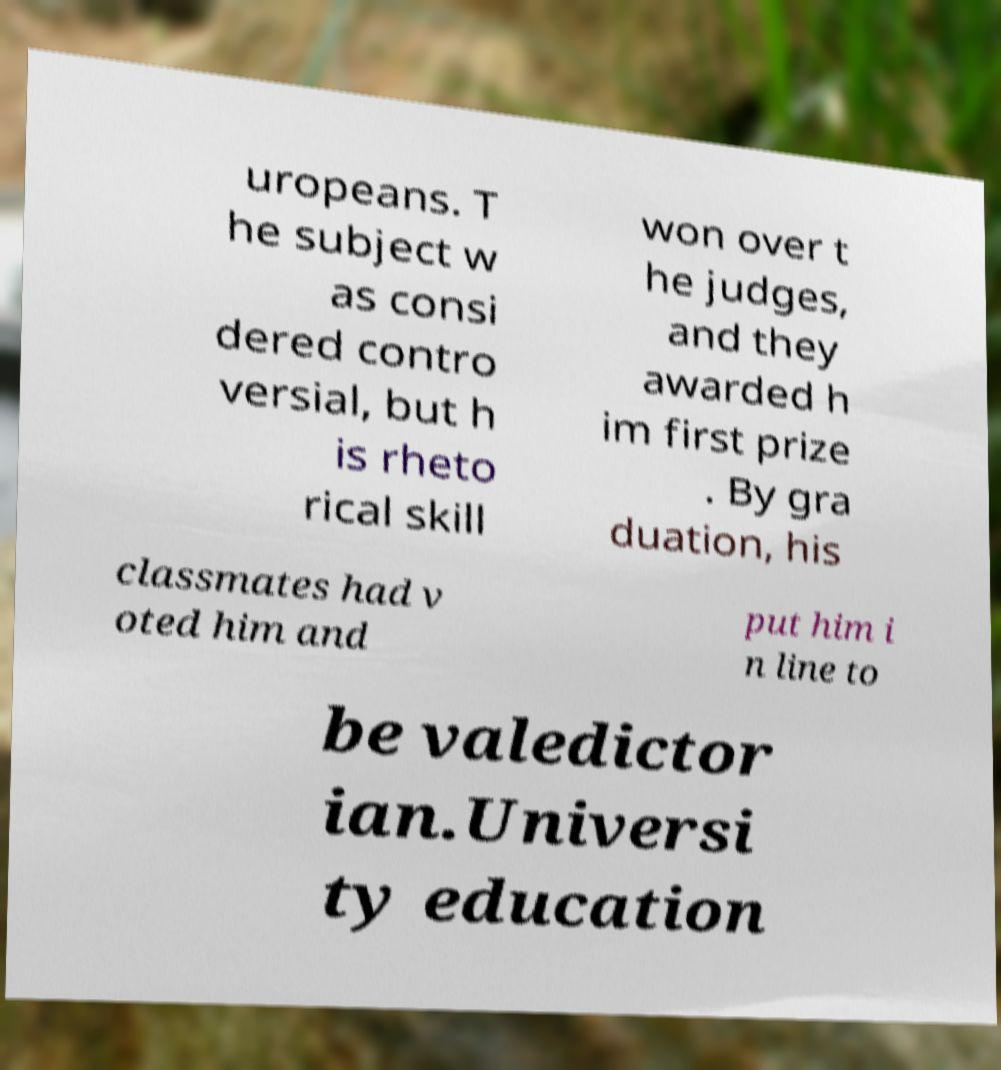I need the written content from this picture converted into text. Can you do that? uropeans. T he subject w as consi dered contro versial, but h is rheto rical skill won over t he judges, and they awarded h im first prize . By gra duation, his classmates had v oted him and put him i n line to be valedictor ian.Universi ty education 